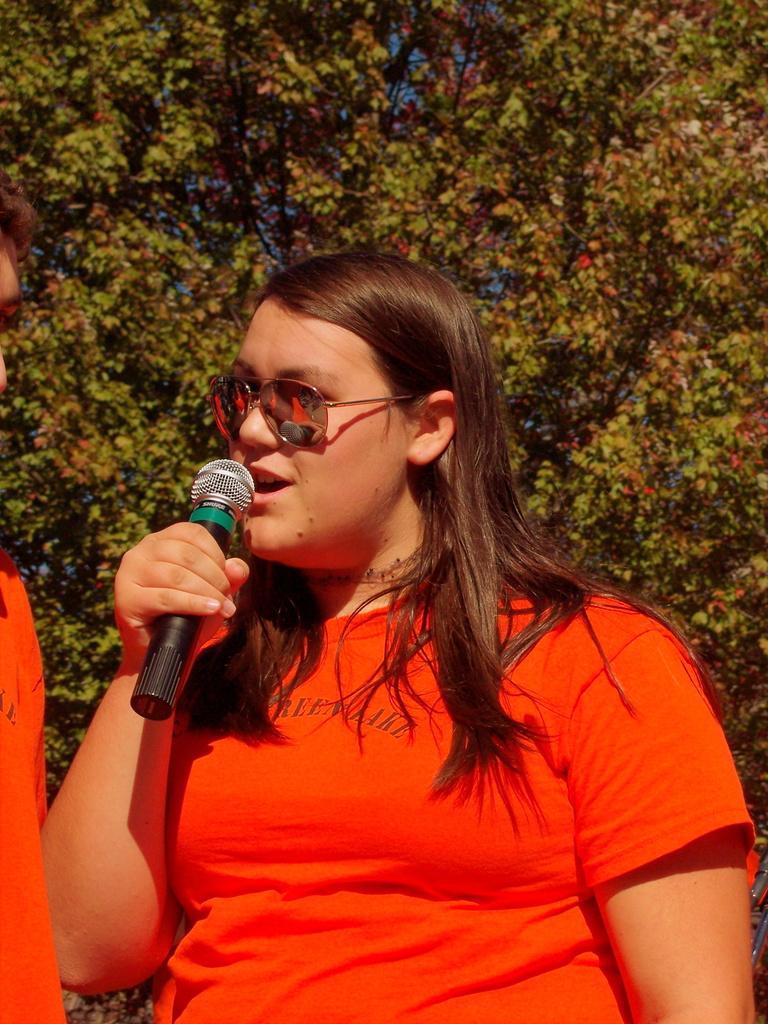Can you describe this image briefly? In the picture we can see a woman holding a microphone, she is wearing a red T-shirt, in the background we can see the trees. 